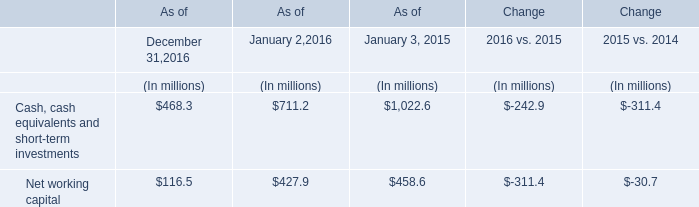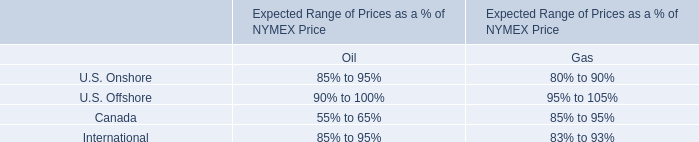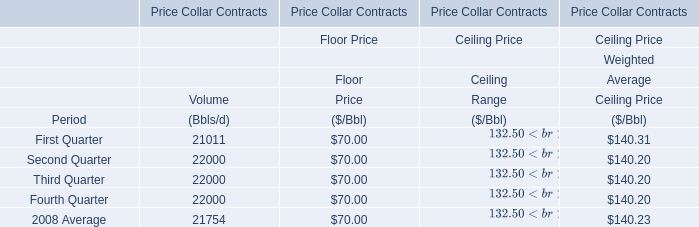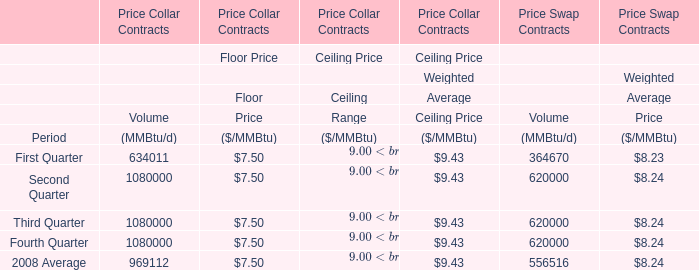What's the average of Volume of Price Collar Contracts in First Quarter, 2008 and Second Quarter, 2008? 
Computations: ((634011 + 1080000) / 2)
Answer: 857005.5. 